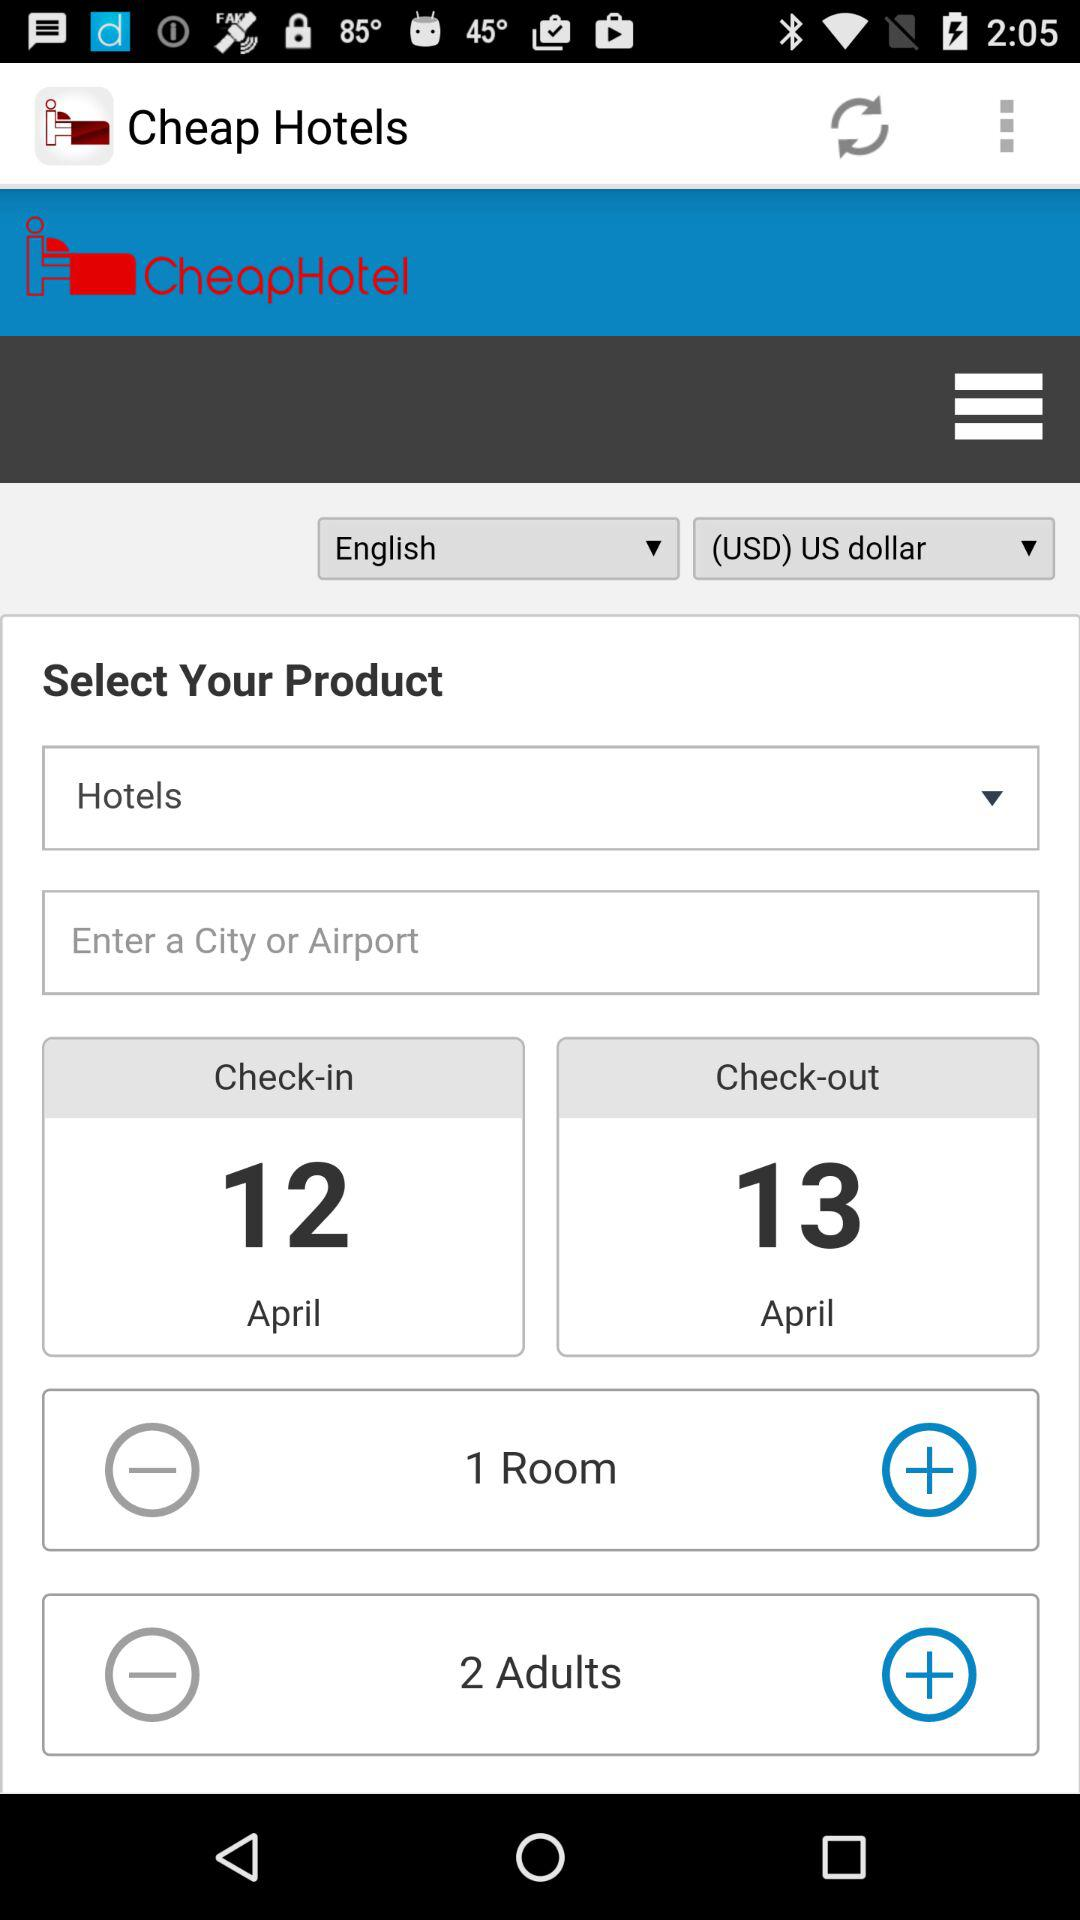When will the check-in be? The check-in will be on April 12. 